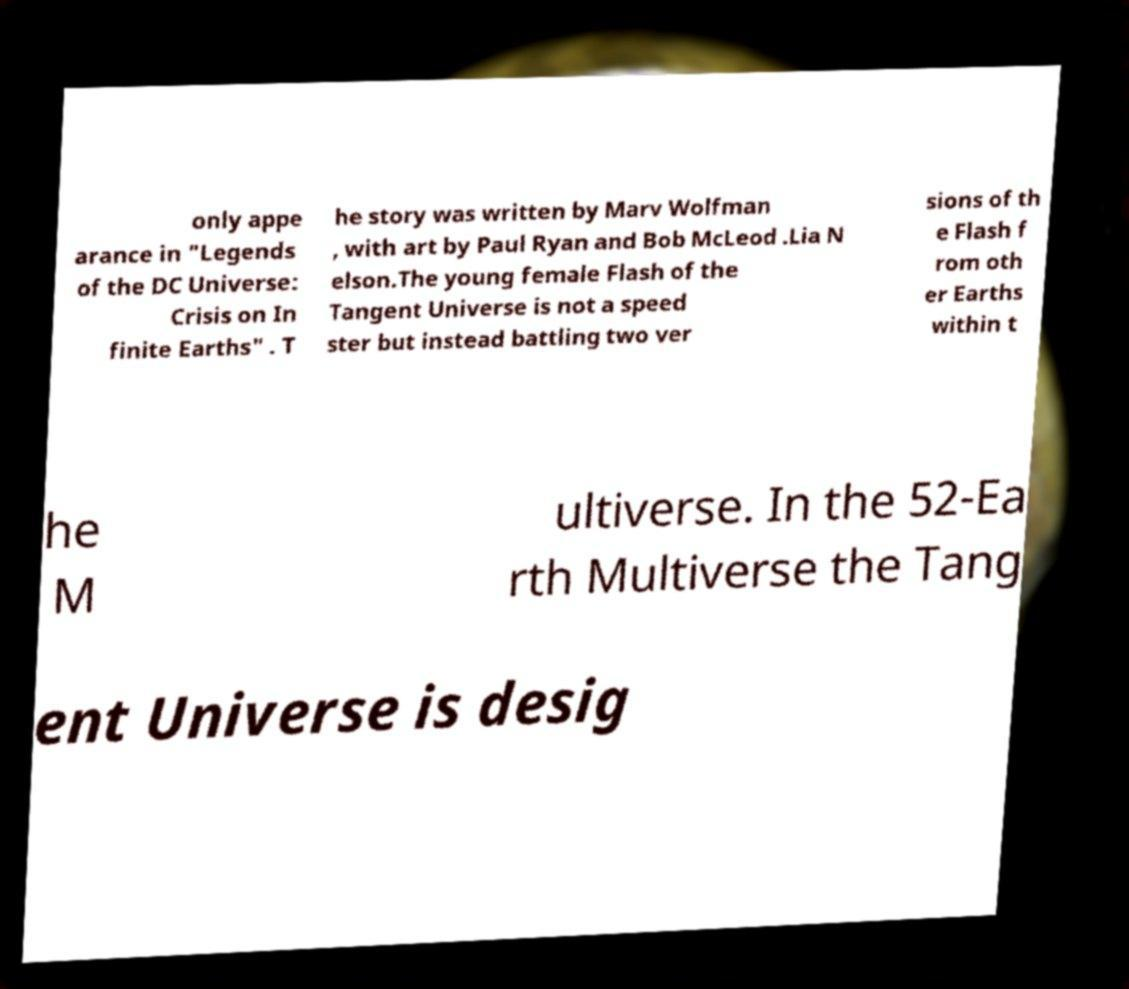There's text embedded in this image that I need extracted. Can you transcribe it verbatim? only appe arance in "Legends of the DC Universe: Crisis on In finite Earths" . T he story was written by Marv Wolfman , with art by Paul Ryan and Bob McLeod .Lia N elson.The young female Flash of the Tangent Universe is not a speed ster but instead battling two ver sions of th e Flash f rom oth er Earths within t he M ultiverse. In the 52-Ea rth Multiverse the Tang ent Universe is desig 